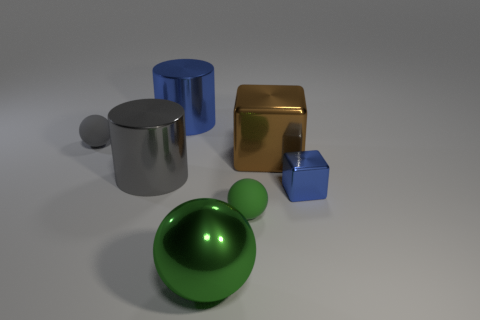Subtract all tiny green matte balls. How many balls are left? 2 Subtract all cyan cubes. How many green balls are left? 2 Add 2 large brown metal blocks. How many objects exist? 9 Subtract all green balls. How many balls are left? 1 Subtract all cylinders. How many objects are left? 5 Subtract all blue spheres. Subtract all yellow cubes. How many spheres are left? 3 Subtract all small green balls. Subtract all large cyan matte objects. How many objects are left? 6 Add 2 big green metallic things. How many big green metallic things are left? 3 Add 1 blue metal objects. How many blue metal objects exist? 3 Subtract 1 gray cylinders. How many objects are left? 6 